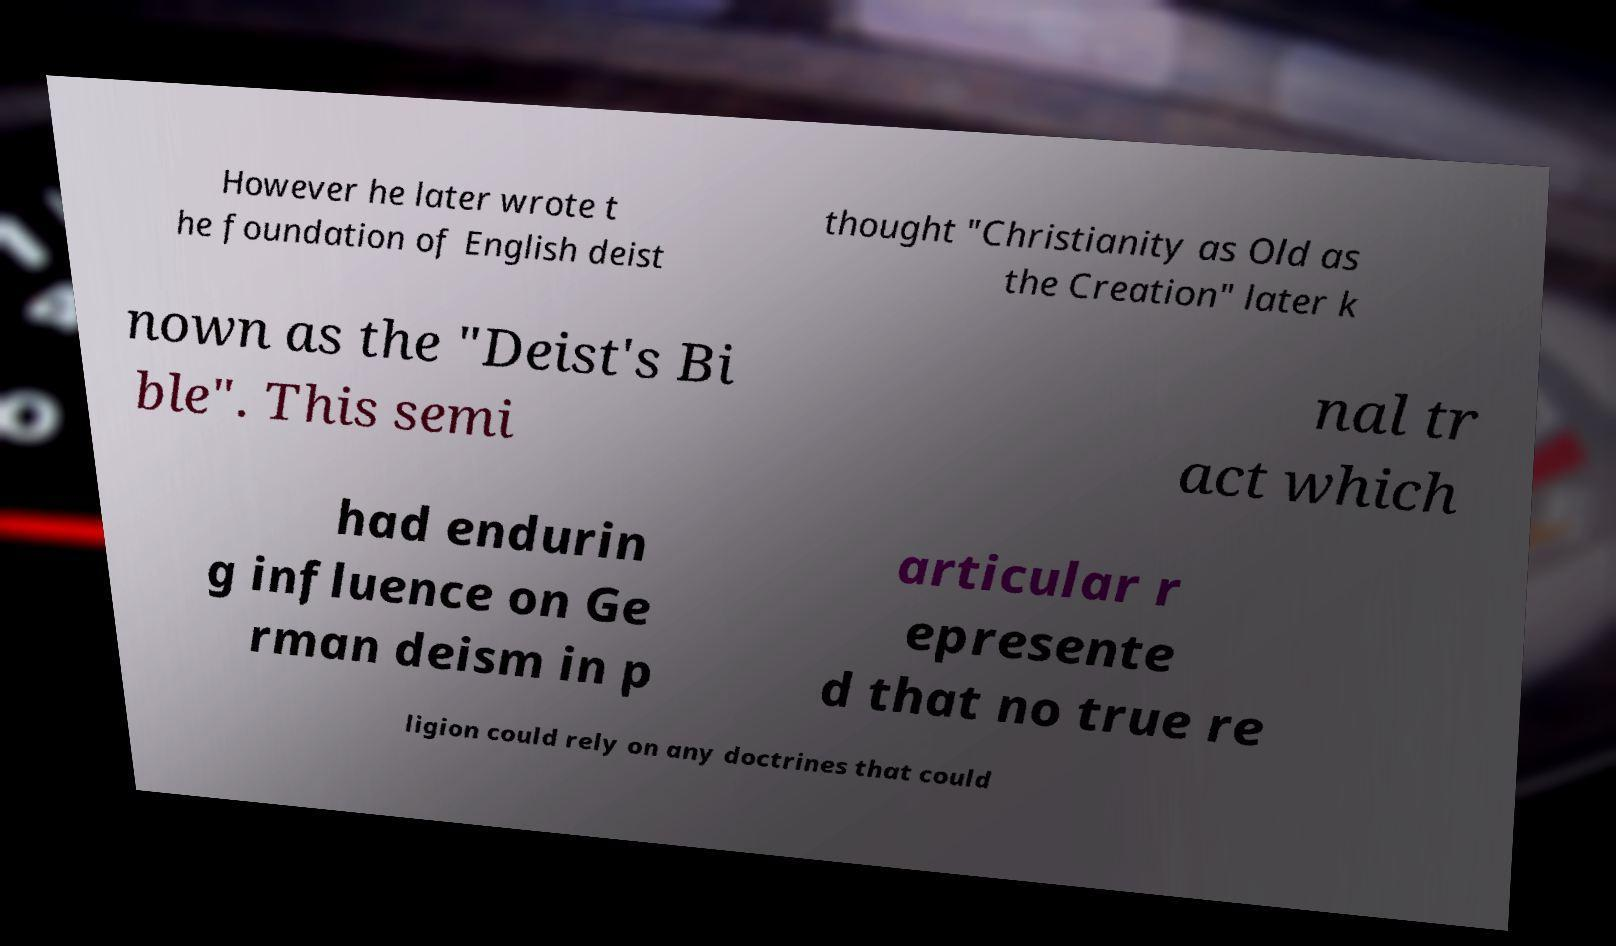Could you assist in decoding the text presented in this image and type it out clearly? However he later wrote t he foundation of English deist thought "Christianity as Old as the Creation" later k nown as the "Deist's Bi ble". This semi nal tr act which had endurin g influence on Ge rman deism in p articular r epresente d that no true re ligion could rely on any doctrines that could 